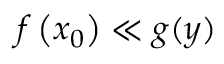<formula> <loc_0><loc_0><loc_500><loc_500>f \left ( x _ { 0 } \right ) \ll g ( y )</formula> 